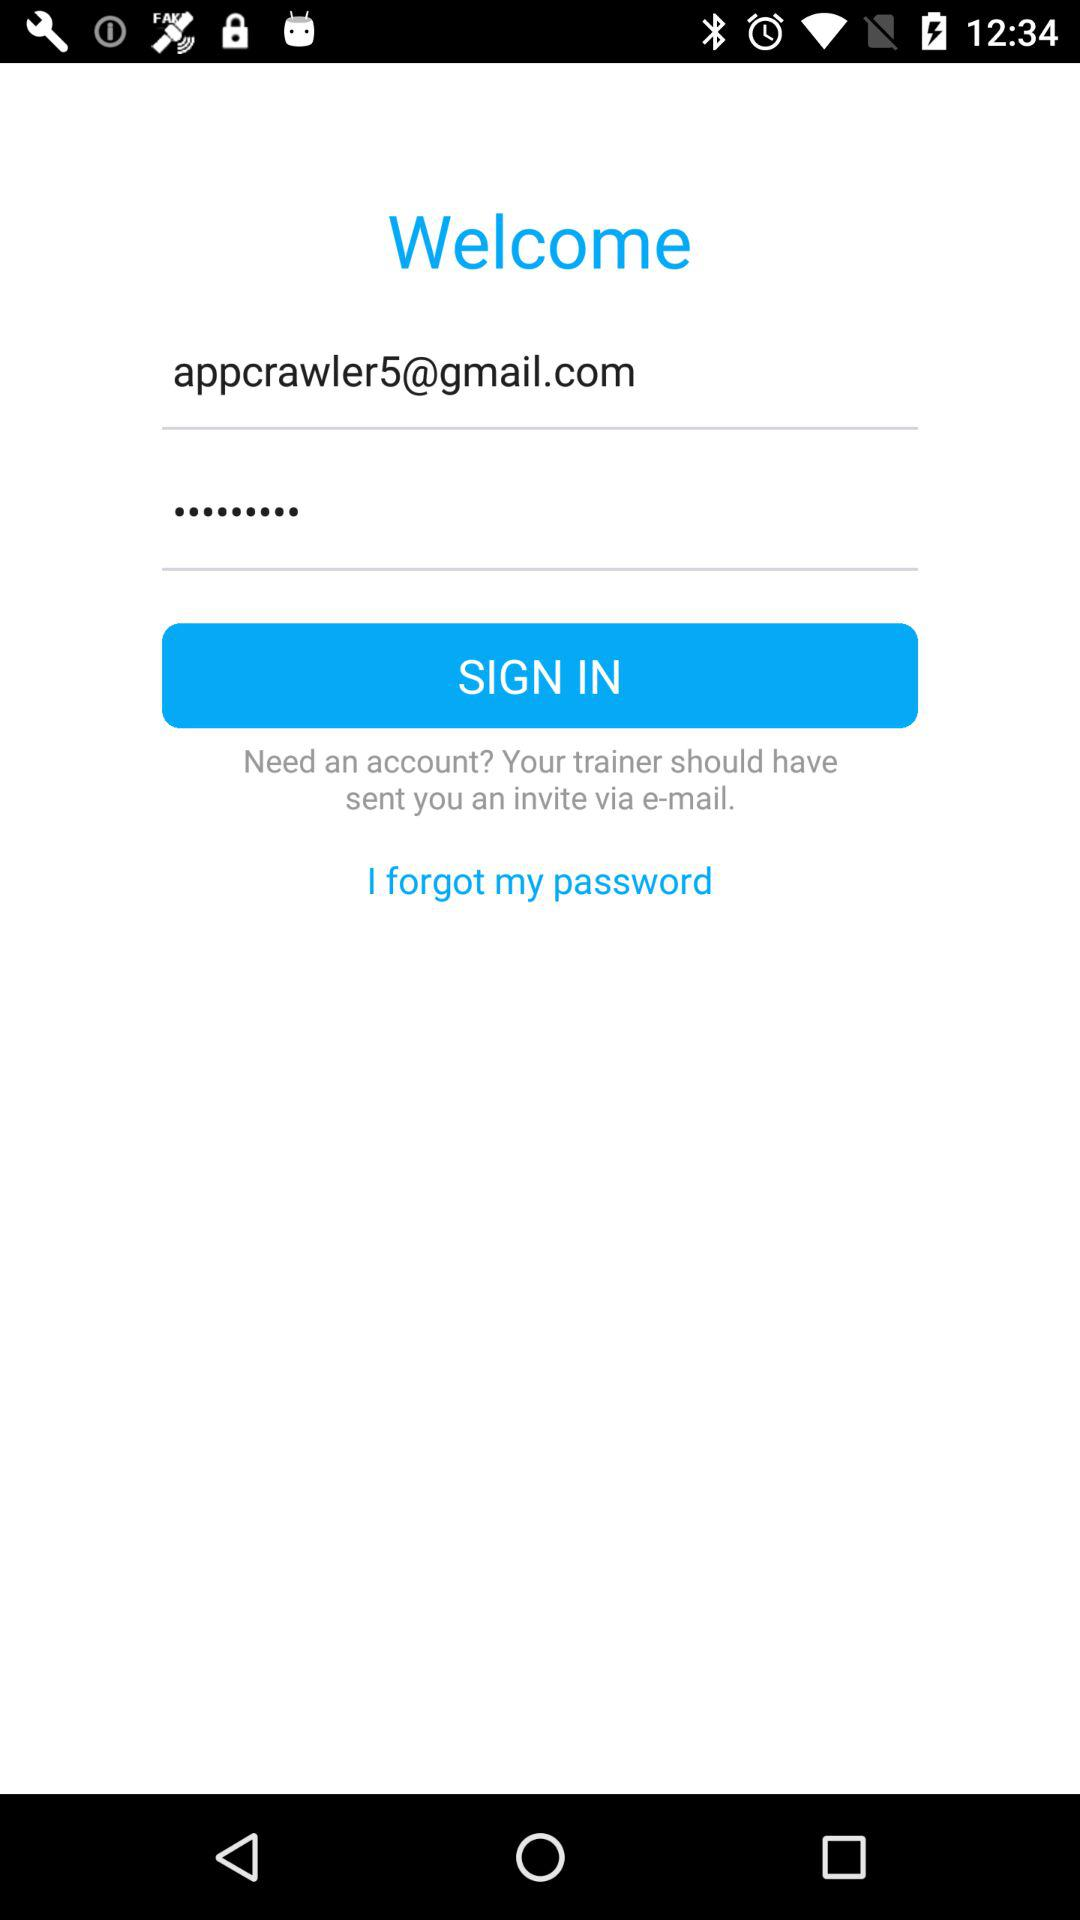How many text inputs are on the screen?
Answer the question using a single word or phrase. 2 